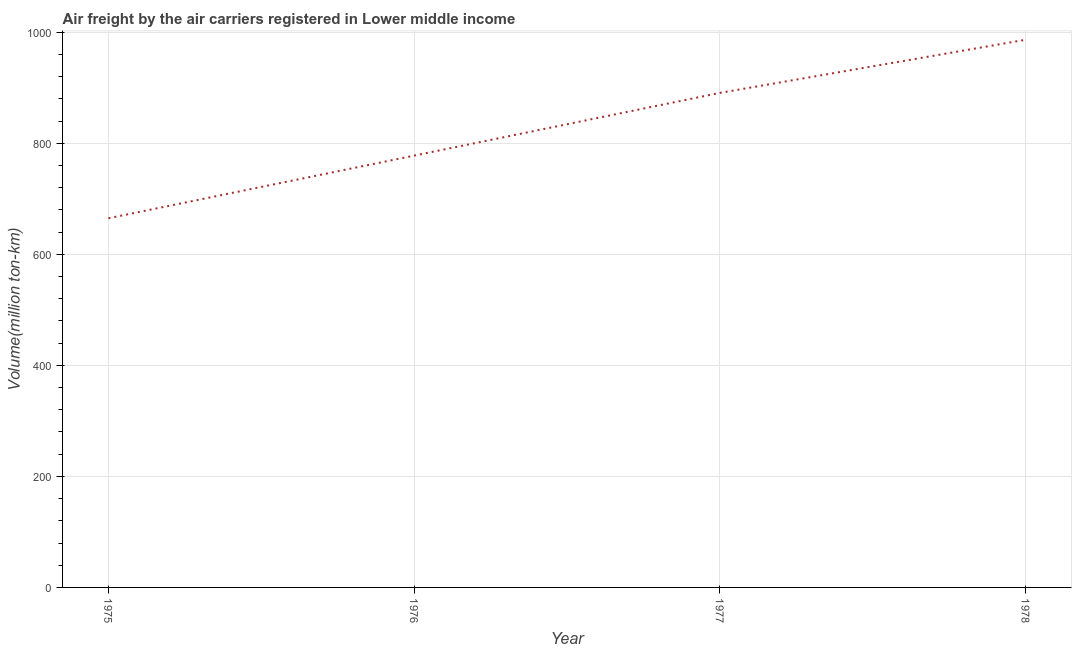What is the air freight in 1978?
Your response must be concise. 986.6. Across all years, what is the maximum air freight?
Offer a very short reply. 986.6. Across all years, what is the minimum air freight?
Your response must be concise. 665. In which year was the air freight maximum?
Give a very brief answer. 1978. In which year was the air freight minimum?
Provide a succinct answer. 1975. What is the sum of the air freight?
Keep it short and to the point. 3320.4. What is the difference between the air freight in 1975 and 1976?
Make the answer very short. -112.9. What is the average air freight per year?
Provide a succinct answer. 830.1. What is the median air freight?
Your answer should be very brief. 834.4. Do a majority of the years between 1977 and 1978 (inclusive) have air freight greater than 680 million ton-km?
Your answer should be compact. Yes. What is the ratio of the air freight in 1975 to that in 1978?
Offer a very short reply. 0.67. Is the air freight in 1976 less than that in 1977?
Give a very brief answer. Yes. What is the difference between the highest and the second highest air freight?
Your answer should be compact. 95.7. What is the difference between the highest and the lowest air freight?
Ensure brevity in your answer.  321.6. In how many years, is the air freight greater than the average air freight taken over all years?
Provide a short and direct response. 2. How many years are there in the graph?
Provide a succinct answer. 4. What is the difference between two consecutive major ticks on the Y-axis?
Give a very brief answer. 200. Are the values on the major ticks of Y-axis written in scientific E-notation?
Offer a terse response. No. What is the title of the graph?
Your answer should be compact. Air freight by the air carriers registered in Lower middle income. What is the label or title of the X-axis?
Ensure brevity in your answer.  Year. What is the label or title of the Y-axis?
Your answer should be compact. Volume(million ton-km). What is the Volume(million ton-km) in 1975?
Give a very brief answer. 665. What is the Volume(million ton-km) in 1976?
Provide a short and direct response. 777.9. What is the Volume(million ton-km) in 1977?
Give a very brief answer. 890.9. What is the Volume(million ton-km) in 1978?
Your answer should be compact. 986.6. What is the difference between the Volume(million ton-km) in 1975 and 1976?
Make the answer very short. -112.9. What is the difference between the Volume(million ton-km) in 1975 and 1977?
Keep it short and to the point. -225.9. What is the difference between the Volume(million ton-km) in 1975 and 1978?
Ensure brevity in your answer.  -321.6. What is the difference between the Volume(million ton-km) in 1976 and 1977?
Provide a succinct answer. -113. What is the difference between the Volume(million ton-km) in 1976 and 1978?
Offer a very short reply. -208.7. What is the difference between the Volume(million ton-km) in 1977 and 1978?
Your response must be concise. -95.7. What is the ratio of the Volume(million ton-km) in 1975 to that in 1976?
Provide a short and direct response. 0.85. What is the ratio of the Volume(million ton-km) in 1975 to that in 1977?
Make the answer very short. 0.75. What is the ratio of the Volume(million ton-km) in 1975 to that in 1978?
Make the answer very short. 0.67. What is the ratio of the Volume(million ton-km) in 1976 to that in 1977?
Offer a terse response. 0.87. What is the ratio of the Volume(million ton-km) in 1976 to that in 1978?
Your response must be concise. 0.79. What is the ratio of the Volume(million ton-km) in 1977 to that in 1978?
Provide a short and direct response. 0.9. 